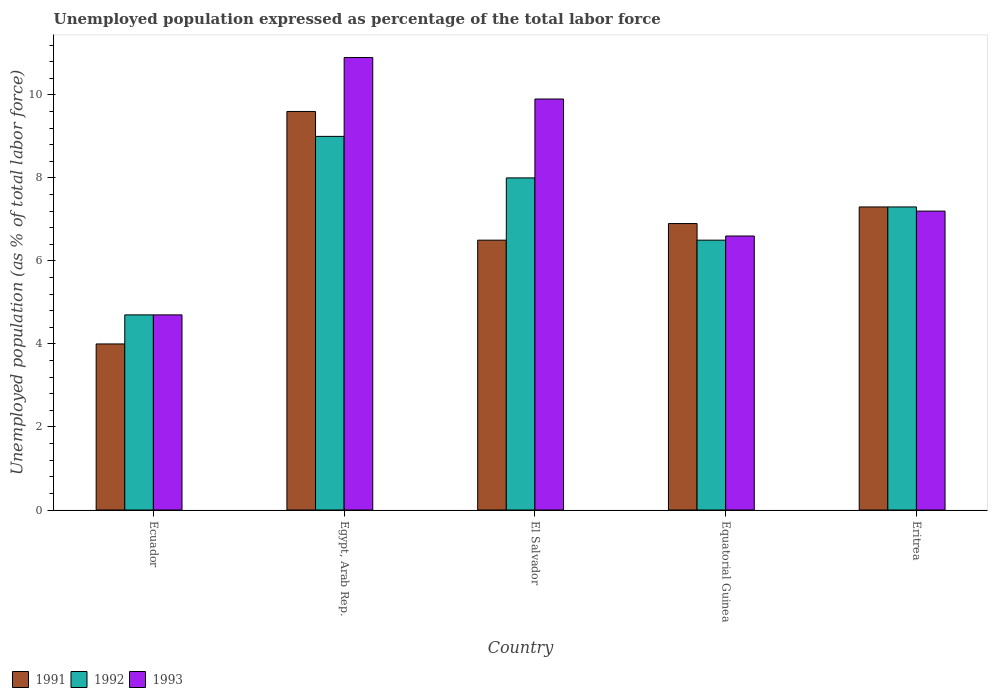How many groups of bars are there?
Your response must be concise. 5. Are the number of bars per tick equal to the number of legend labels?
Your answer should be very brief. Yes. How many bars are there on the 1st tick from the left?
Keep it short and to the point. 3. What is the label of the 4th group of bars from the left?
Ensure brevity in your answer.  Equatorial Guinea. In how many cases, is the number of bars for a given country not equal to the number of legend labels?
Provide a short and direct response. 0. What is the unemployment in in 1992 in El Salvador?
Provide a short and direct response. 8. Across all countries, what is the maximum unemployment in in 1993?
Give a very brief answer. 10.9. Across all countries, what is the minimum unemployment in in 1991?
Provide a succinct answer. 4. In which country was the unemployment in in 1993 maximum?
Offer a very short reply. Egypt, Arab Rep. In which country was the unemployment in in 1992 minimum?
Give a very brief answer. Ecuador. What is the total unemployment in in 1991 in the graph?
Your response must be concise. 34.3. What is the difference between the unemployment in in 1992 in El Salvador and that in Equatorial Guinea?
Offer a terse response. 1.5. What is the difference between the unemployment in in 1991 in Eritrea and the unemployment in in 1993 in El Salvador?
Your answer should be very brief. -2.6. What is the average unemployment in in 1993 per country?
Your answer should be compact. 7.86. What is the difference between the unemployment in of/in 1992 and unemployment in of/in 1993 in El Salvador?
Your answer should be very brief. -1.9. In how many countries, is the unemployment in in 1991 greater than 3.6 %?
Offer a very short reply. 5. What is the ratio of the unemployment in in 1993 in Ecuador to that in El Salvador?
Offer a terse response. 0.47. Is the unemployment in in 1991 in Equatorial Guinea less than that in Eritrea?
Make the answer very short. Yes. What is the difference between the highest and the second highest unemployment in in 1993?
Provide a short and direct response. -1. What is the difference between the highest and the lowest unemployment in in 1993?
Offer a terse response. 6.2. In how many countries, is the unemployment in in 1992 greater than the average unemployment in in 1992 taken over all countries?
Ensure brevity in your answer.  3. Is it the case that in every country, the sum of the unemployment in in 1993 and unemployment in in 1992 is greater than the unemployment in in 1991?
Your answer should be very brief. Yes. How many countries are there in the graph?
Provide a short and direct response. 5. What is the difference between two consecutive major ticks on the Y-axis?
Provide a short and direct response. 2. Are the values on the major ticks of Y-axis written in scientific E-notation?
Your answer should be very brief. No. Does the graph contain grids?
Keep it short and to the point. No. How are the legend labels stacked?
Provide a short and direct response. Horizontal. What is the title of the graph?
Your answer should be very brief. Unemployed population expressed as percentage of the total labor force. What is the label or title of the Y-axis?
Give a very brief answer. Unemployed population (as % of total labor force). What is the Unemployed population (as % of total labor force) of 1991 in Ecuador?
Provide a short and direct response. 4. What is the Unemployed population (as % of total labor force) in 1992 in Ecuador?
Your response must be concise. 4.7. What is the Unemployed population (as % of total labor force) of 1993 in Ecuador?
Provide a succinct answer. 4.7. What is the Unemployed population (as % of total labor force) of 1991 in Egypt, Arab Rep.?
Ensure brevity in your answer.  9.6. What is the Unemployed population (as % of total labor force) of 1993 in Egypt, Arab Rep.?
Provide a succinct answer. 10.9. What is the Unemployed population (as % of total labor force) of 1993 in El Salvador?
Your answer should be compact. 9.9. What is the Unemployed population (as % of total labor force) in 1991 in Equatorial Guinea?
Provide a succinct answer. 6.9. What is the Unemployed population (as % of total labor force) of 1993 in Equatorial Guinea?
Your response must be concise. 6.6. What is the Unemployed population (as % of total labor force) of 1991 in Eritrea?
Keep it short and to the point. 7.3. What is the Unemployed population (as % of total labor force) in 1992 in Eritrea?
Your answer should be compact. 7.3. What is the Unemployed population (as % of total labor force) in 1993 in Eritrea?
Your answer should be very brief. 7.2. Across all countries, what is the maximum Unemployed population (as % of total labor force) in 1991?
Make the answer very short. 9.6. Across all countries, what is the maximum Unemployed population (as % of total labor force) in 1993?
Ensure brevity in your answer.  10.9. Across all countries, what is the minimum Unemployed population (as % of total labor force) of 1992?
Give a very brief answer. 4.7. Across all countries, what is the minimum Unemployed population (as % of total labor force) of 1993?
Provide a short and direct response. 4.7. What is the total Unemployed population (as % of total labor force) in 1991 in the graph?
Give a very brief answer. 34.3. What is the total Unemployed population (as % of total labor force) in 1992 in the graph?
Keep it short and to the point. 35.5. What is the total Unemployed population (as % of total labor force) in 1993 in the graph?
Give a very brief answer. 39.3. What is the difference between the Unemployed population (as % of total labor force) of 1993 in Ecuador and that in Egypt, Arab Rep.?
Your answer should be compact. -6.2. What is the difference between the Unemployed population (as % of total labor force) in 1991 in Ecuador and that in Equatorial Guinea?
Give a very brief answer. -2.9. What is the difference between the Unemployed population (as % of total labor force) in 1993 in Ecuador and that in Eritrea?
Make the answer very short. -2.5. What is the difference between the Unemployed population (as % of total labor force) of 1993 in Egypt, Arab Rep. and that in El Salvador?
Give a very brief answer. 1. What is the difference between the Unemployed population (as % of total labor force) in 1991 in Egypt, Arab Rep. and that in Equatorial Guinea?
Your response must be concise. 2.7. What is the difference between the Unemployed population (as % of total labor force) of 1992 in Egypt, Arab Rep. and that in Equatorial Guinea?
Offer a very short reply. 2.5. What is the difference between the Unemployed population (as % of total labor force) of 1993 in Egypt, Arab Rep. and that in Eritrea?
Provide a succinct answer. 3.7. What is the difference between the Unemployed population (as % of total labor force) of 1991 in El Salvador and that in Equatorial Guinea?
Provide a succinct answer. -0.4. What is the difference between the Unemployed population (as % of total labor force) in 1992 in El Salvador and that in Equatorial Guinea?
Offer a very short reply. 1.5. What is the difference between the Unemployed population (as % of total labor force) of 1992 in El Salvador and that in Eritrea?
Offer a very short reply. 0.7. What is the difference between the Unemployed population (as % of total labor force) of 1993 in El Salvador and that in Eritrea?
Keep it short and to the point. 2.7. What is the difference between the Unemployed population (as % of total labor force) in 1993 in Equatorial Guinea and that in Eritrea?
Your response must be concise. -0.6. What is the difference between the Unemployed population (as % of total labor force) of 1991 in Ecuador and the Unemployed population (as % of total labor force) of 1992 in Egypt, Arab Rep.?
Give a very brief answer. -5. What is the difference between the Unemployed population (as % of total labor force) in 1991 in Ecuador and the Unemployed population (as % of total labor force) in 1992 in El Salvador?
Provide a succinct answer. -4. What is the difference between the Unemployed population (as % of total labor force) in 1991 in Ecuador and the Unemployed population (as % of total labor force) in 1993 in El Salvador?
Offer a very short reply. -5.9. What is the difference between the Unemployed population (as % of total labor force) of 1991 in Ecuador and the Unemployed population (as % of total labor force) of 1992 in Equatorial Guinea?
Give a very brief answer. -2.5. What is the difference between the Unemployed population (as % of total labor force) in 1991 in Ecuador and the Unemployed population (as % of total labor force) in 1993 in Equatorial Guinea?
Your answer should be very brief. -2.6. What is the difference between the Unemployed population (as % of total labor force) of 1992 in Ecuador and the Unemployed population (as % of total labor force) of 1993 in Equatorial Guinea?
Offer a terse response. -1.9. What is the difference between the Unemployed population (as % of total labor force) in 1991 in Ecuador and the Unemployed population (as % of total labor force) in 1993 in Eritrea?
Your response must be concise. -3.2. What is the difference between the Unemployed population (as % of total labor force) of 1992 in Ecuador and the Unemployed population (as % of total labor force) of 1993 in Eritrea?
Offer a very short reply. -2.5. What is the difference between the Unemployed population (as % of total labor force) in 1991 in Egypt, Arab Rep. and the Unemployed population (as % of total labor force) in 1993 in El Salvador?
Make the answer very short. -0.3. What is the difference between the Unemployed population (as % of total labor force) of 1992 in Egypt, Arab Rep. and the Unemployed population (as % of total labor force) of 1993 in El Salvador?
Make the answer very short. -0.9. What is the difference between the Unemployed population (as % of total labor force) of 1991 in Egypt, Arab Rep. and the Unemployed population (as % of total labor force) of 1993 in Equatorial Guinea?
Your response must be concise. 3. What is the difference between the Unemployed population (as % of total labor force) in 1991 in Egypt, Arab Rep. and the Unemployed population (as % of total labor force) in 1992 in Eritrea?
Provide a succinct answer. 2.3. What is the difference between the Unemployed population (as % of total labor force) in 1991 in Egypt, Arab Rep. and the Unemployed population (as % of total labor force) in 1993 in Eritrea?
Ensure brevity in your answer.  2.4. What is the difference between the Unemployed population (as % of total labor force) of 1991 in El Salvador and the Unemployed population (as % of total labor force) of 1993 in Equatorial Guinea?
Offer a very short reply. -0.1. What is the difference between the Unemployed population (as % of total labor force) of 1992 in Equatorial Guinea and the Unemployed population (as % of total labor force) of 1993 in Eritrea?
Offer a terse response. -0.7. What is the average Unemployed population (as % of total labor force) of 1991 per country?
Offer a terse response. 6.86. What is the average Unemployed population (as % of total labor force) of 1992 per country?
Your answer should be very brief. 7.1. What is the average Unemployed population (as % of total labor force) in 1993 per country?
Give a very brief answer. 7.86. What is the difference between the Unemployed population (as % of total labor force) in 1991 and Unemployed population (as % of total labor force) in 1992 in Ecuador?
Make the answer very short. -0.7. What is the difference between the Unemployed population (as % of total labor force) of 1992 and Unemployed population (as % of total labor force) of 1993 in Ecuador?
Provide a succinct answer. 0. What is the difference between the Unemployed population (as % of total labor force) in 1991 and Unemployed population (as % of total labor force) in 1992 in El Salvador?
Make the answer very short. -1.5. What is the difference between the Unemployed population (as % of total labor force) of 1991 and Unemployed population (as % of total labor force) of 1993 in El Salvador?
Keep it short and to the point. -3.4. What is the difference between the Unemployed population (as % of total labor force) of 1992 and Unemployed population (as % of total labor force) of 1993 in El Salvador?
Offer a terse response. -1.9. What is the difference between the Unemployed population (as % of total labor force) in 1992 and Unemployed population (as % of total labor force) in 1993 in Equatorial Guinea?
Provide a succinct answer. -0.1. What is the difference between the Unemployed population (as % of total labor force) in 1992 and Unemployed population (as % of total labor force) in 1993 in Eritrea?
Make the answer very short. 0.1. What is the ratio of the Unemployed population (as % of total labor force) in 1991 in Ecuador to that in Egypt, Arab Rep.?
Ensure brevity in your answer.  0.42. What is the ratio of the Unemployed population (as % of total labor force) of 1992 in Ecuador to that in Egypt, Arab Rep.?
Your answer should be compact. 0.52. What is the ratio of the Unemployed population (as % of total labor force) of 1993 in Ecuador to that in Egypt, Arab Rep.?
Offer a terse response. 0.43. What is the ratio of the Unemployed population (as % of total labor force) of 1991 in Ecuador to that in El Salvador?
Your response must be concise. 0.62. What is the ratio of the Unemployed population (as % of total labor force) of 1992 in Ecuador to that in El Salvador?
Ensure brevity in your answer.  0.59. What is the ratio of the Unemployed population (as % of total labor force) of 1993 in Ecuador to that in El Salvador?
Keep it short and to the point. 0.47. What is the ratio of the Unemployed population (as % of total labor force) in 1991 in Ecuador to that in Equatorial Guinea?
Your answer should be compact. 0.58. What is the ratio of the Unemployed population (as % of total labor force) in 1992 in Ecuador to that in Equatorial Guinea?
Make the answer very short. 0.72. What is the ratio of the Unemployed population (as % of total labor force) in 1993 in Ecuador to that in Equatorial Guinea?
Provide a succinct answer. 0.71. What is the ratio of the Unemployed population (as % of total labor force) of 1991 in Ecuador to that in Eritrea?
Offer a very short reply. 0.55. What is the ratio of the Unemployed population (as % of total labor force) in 1992 in Ecuador to that in Eritrea?
Keep it short and to the point. 0.64. What is the ratio of the Unemployed population (as % of total labor force) of 1993 in Ecuador to that in Eritrea?
Offer a very short reply. 0.65. What is the ratio of the Unemployed population (as % of total labor force) in 1991 in Egypt, Arab Rep. to that in El Salvador?
Provide a succinct answer. 1.48. What is the ratio of the Unemployed population (as % of total labor force) in 1993 in Egypt, Arab Rep. to that in El Salvador?
Offer a very short reply. 1.1. What is the ratio of the Unemployed population (as % of total labor force) of 1991 in Egypt, Arab Rep. to that in Equatorial Guinea?
Give a very brief answer. 1.39. What is the ratio of the Unemployed population (as % of total labor force) of 1992 in Egypt, Arab Rep. to that in Equatorial Guinea?
Offer a very short reply. 1.38. What is the ratio of the Unemployed population (as % of total labor force) in 1993 in Egypt, Arab Rep. to that in Equatorial Guinea?
Ensure brevity in your answer.  1.65. What is the ratio of the Unemployed population (as % of total labor force) in 1991 in Egypt, Arab Rep. to that in Eritrea?
Offer a very short reply. 1.32. What is the ratio of the Unemployed population (as % of total labor force) of 1992 in Egypt, Arab Rep. to that in Eritrea?
Ensure brevity in your answer.  1.23. What is the ratio of the Unemployed population (as % of total labor force) of 1993 in Egypt, Arab Rep. to that in Eritrea?
Your response must be concise. 1.51. What is the ratio of the Unemployed population (as % of total labor force) of 1991 in El Salvador to that in Equatorial Guinea?
Provide a short and direct response. 0.94. What is the ratio of the Unemployed population (as % of total labor force) of 1992 in El Salvador to that in Equatorial Guinea?
Your answer should be compact. 1.23. What is the ratio of the Unemployed population (as % of total labor force) of 1993 in El Salvador to that in Equatorial Guinea?
Provide a short and direct response. 1.5. What is the ratio of the Unemployed population (as % of total labor force) of 1991 in El Salvador to that in Eritrea?
Provide a short and direct response. 0.89. What is the ratio of the Unemployed population (as % of total labor force) in 1992 in El Salvador to that in Eritrea?
Provide a short and direct response. 1.1. What is the ratio of the Unemployed population (as % of total labor force) in 1993 in El Salvador to that in Eritrea?
Provide a succinct answer. 1.38. What is the ratio of the Unemployed population (as % of total labor force) of 1991 in Equatorial Guinea to that in Eritrea?
Your response must be concise. 0.95. What is the ratio of the Unemployed population (as % of total labor force) in 1992 in Equatorial Guinea to that in Eritrea?
Provide a succinct answer. 0.89. What is the difference between the highest and the second highest Unemployed population (as % of total labor force) of 1991?
Your response must be concise. 2.3. What is the difference between the highest and the lowest Unemployed population (as % of total labor force) in 1991?
Give a very brief answer. 5.6. What is the difference between the highest and the lowest Unemployed population (as % of total labor force) in 1993?
Your answer should be very brief. 6.2. 